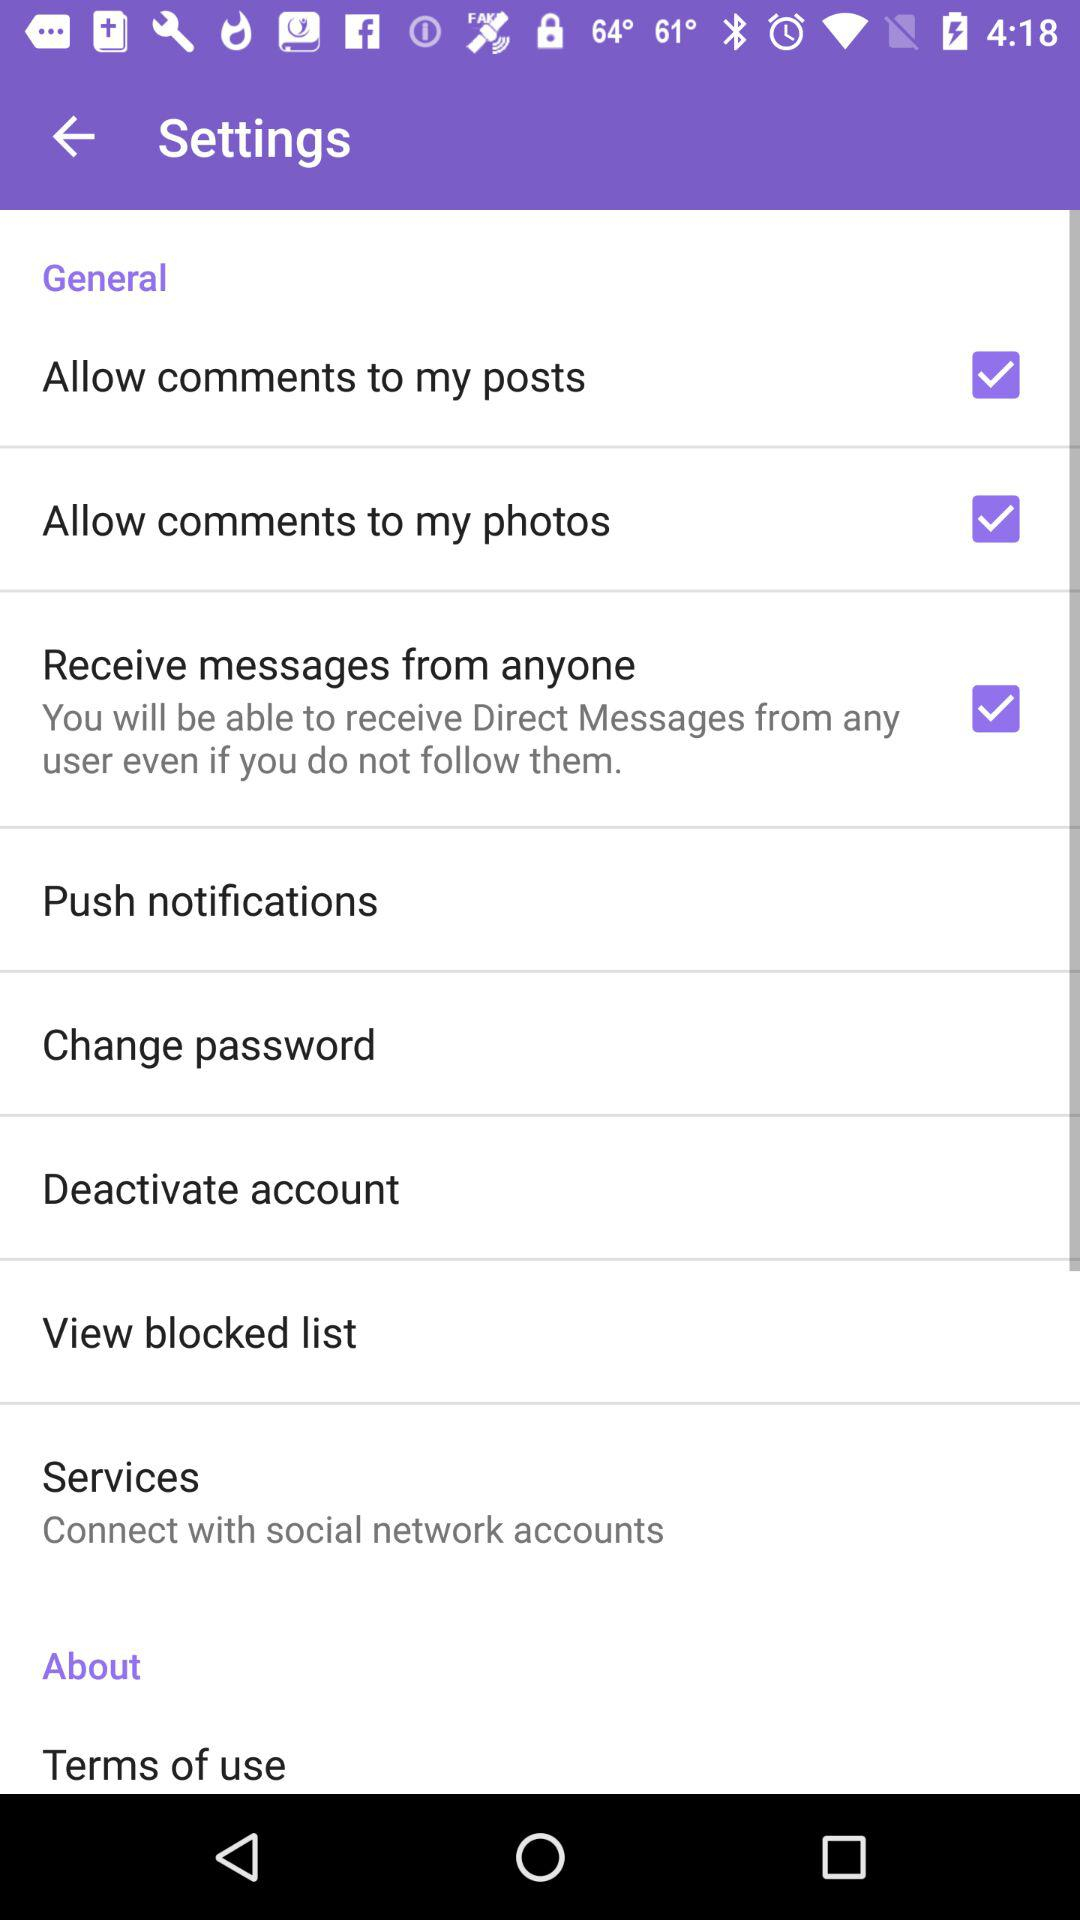What is the status of "Allow comments to my photos"? The status of "Allow comments to my photos" is "on". 